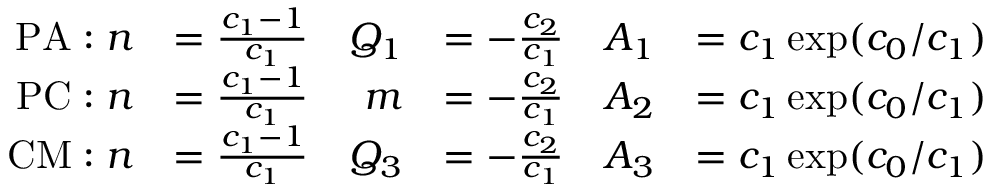Convert formula to latex. <formula><loc_0><loc_0><loc_500><loc_500>\begin{array} { r l r l r l } { P A \colon n } & { = \frac { c _ { 1 } - 1 } { c _ { 1 } } } & { Q _ { 1 } } & { = - \frac { c _ { 2 } } { c _ { 1 } } } & { A _ { 1 } } & { = c _ { 1 } \exp ( c _ { 0 } / c _ { 1 } ) } \\ { P C \colon n } & { = \frac { c _ { 1 } - 1 } { c _ { 1 } } } & { m } & { = - \frac { c _ { 2 } } { c _ { 1 } } } & { A _ { 2 } } & { = c _ { 1 } \exp ( c _ { 0 } / c _ { 1 } ) } \\ { C M \colon n } & { = \frac { c _ { 1 } - 1 } { c _ { 1 } } } & { Q _ { 3 } } & { = - \frac { c _ { 2 } } { c _ { 1 } } } & { A _ { 3 } } & { = c _ { 1 } \exp ( c _ { 0 } / c _ { 1 } ) } \end{array}</formula> 